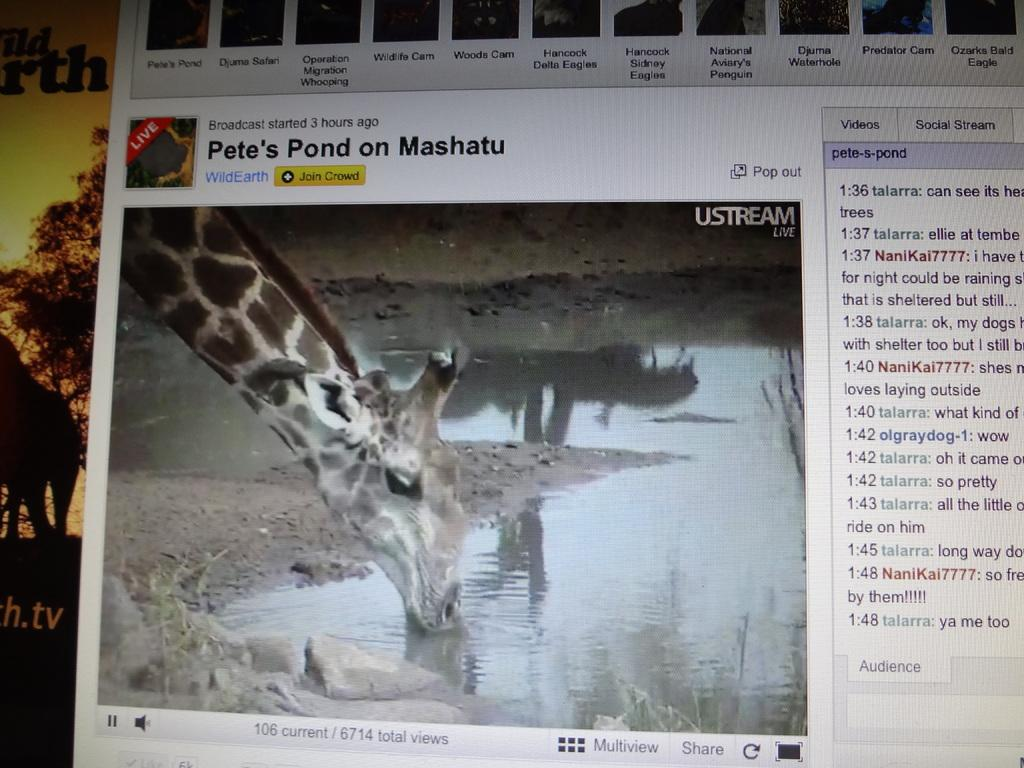What type of image is shown in the screenshot? The image does not specify the content of the screenshot, so we cannot determine the type of image shown. What kind of animal can be seen in the image? There is an animal visible in the image. Can you describe the text written on the image? The text written on the image is not specified, so we cannot describe its content. How many geese are standing on the hydrant in the image? There is no hydrant or geese present in the image. What color is the sock in the image? There is no sock present in the image. 